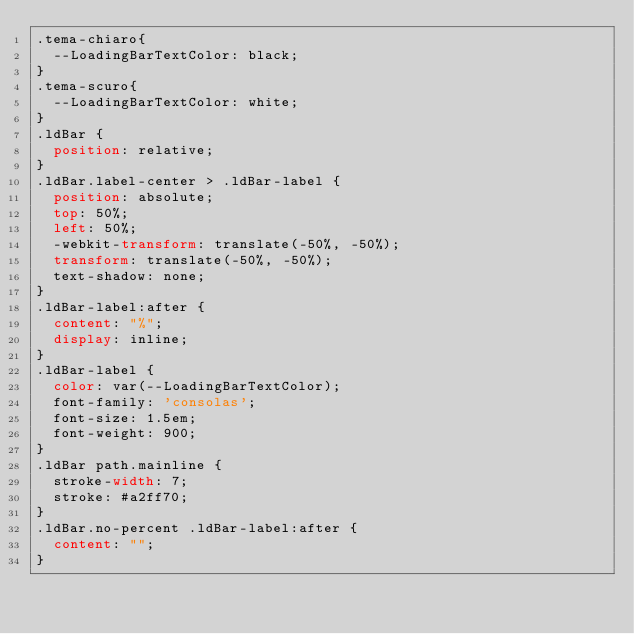Convert code to text. <code><loc_0><loc_0><loc_500><loc_500><_CSS_>.tema-chiaro{
  --LoadingBarTextColor: black;
}
.tema-scuro{
  --LoadingBarTextColor: white;
}
.ldBar {
  position: relative;
}
.ldBar.label-center > .ldBar-label {
  position: absolute;
  top: 50%;
  left: 50%;
  -webkit-transform: translate(-50%, -50%);
  transform: translate(-50%, -50%);
  text-shadow: none;
}
.ldBar-label:after {
  content: "%";
  display: inline;
}
.ldBar-label {
	color: var(--LoadingBarTextColor);
  font-family: 'consolas';
  font-size: 1.5em;
  font-weight: 900;
}
.ldBar path.mainline {
  stroke-width: 7;
  stroke: #a2ff70;
}
.ldBar.no-percent .ldBar-label:after {
  content: "";
}</code> 